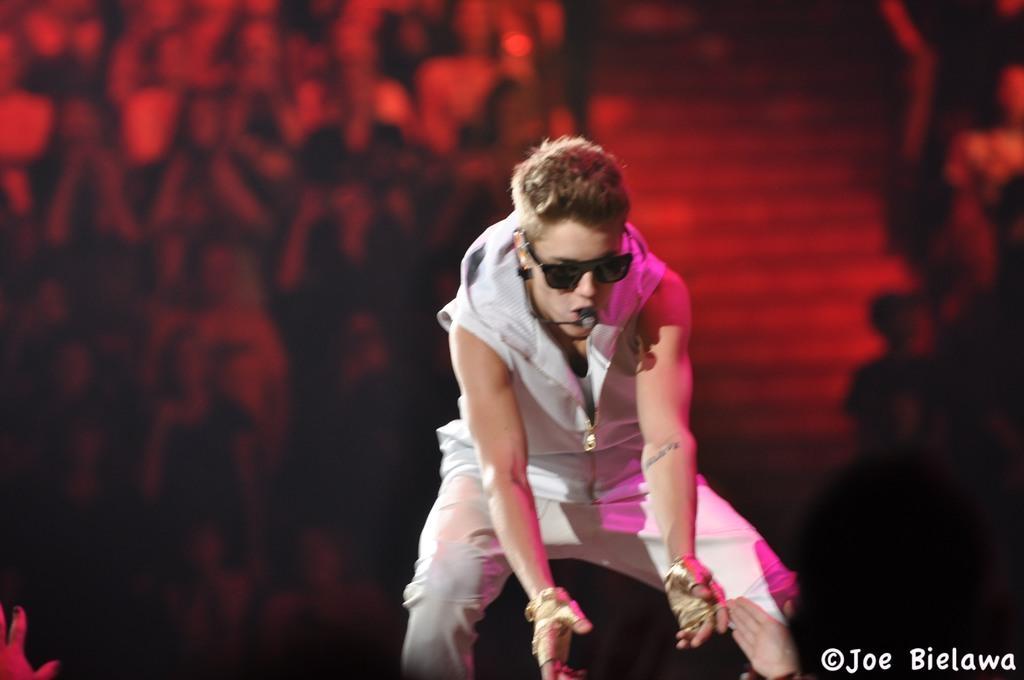Could you give a brief overview of what you see in this image? In this image we can see a group of people behind a person. There are staircases in the image. A person is speaking into a microphone. 